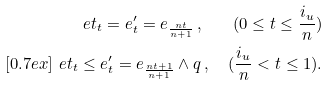<formula> <loc_0><loc_0><loc_500><loc_500>\ e t _ { t } = e ^ { \prime } _ { t } = e _ { \frac { n t } { n + 1 } } \, , \quad ( 0 \leq t \leq \frac { i _ { u } } n ) \\ [ 0 . 7 e x ] \ e t _ { t } \leq e ^ { \prime } _ { t } = e _ { \frac { n t + 1 } { n + 1 } } \wedge q \, , \quad ( \frac { i _ { u } } n < t \leq 1 ) .</formula> 